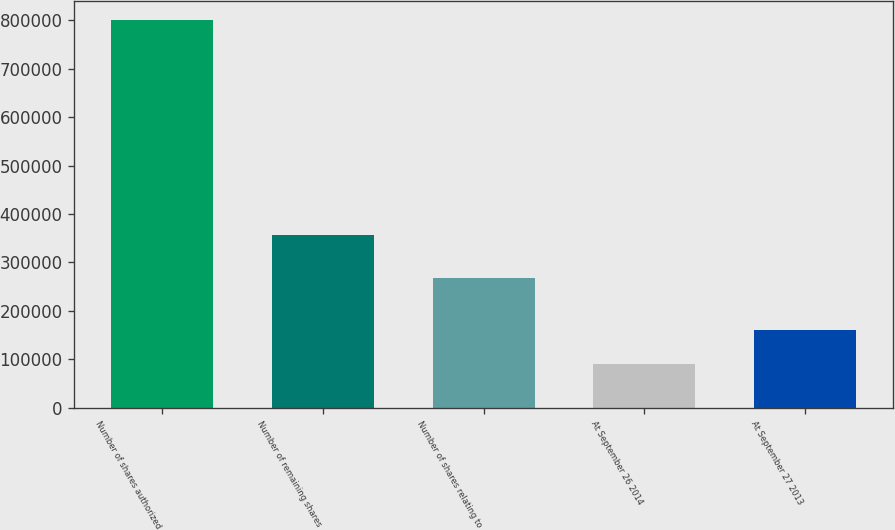<chart> <loc_0><loc_0><loc_500><loc_500><bar_chart><fcel>Number of shares authorized<fcel>Number of remaining shares<fcel>Number of shares relating to<fcel>At September 26 2014<fcel>At September 27 2013<nl><fcel>800000<fcel>357000<fcel>266875<fcel>90125<fcel>161112<nl></chart> 